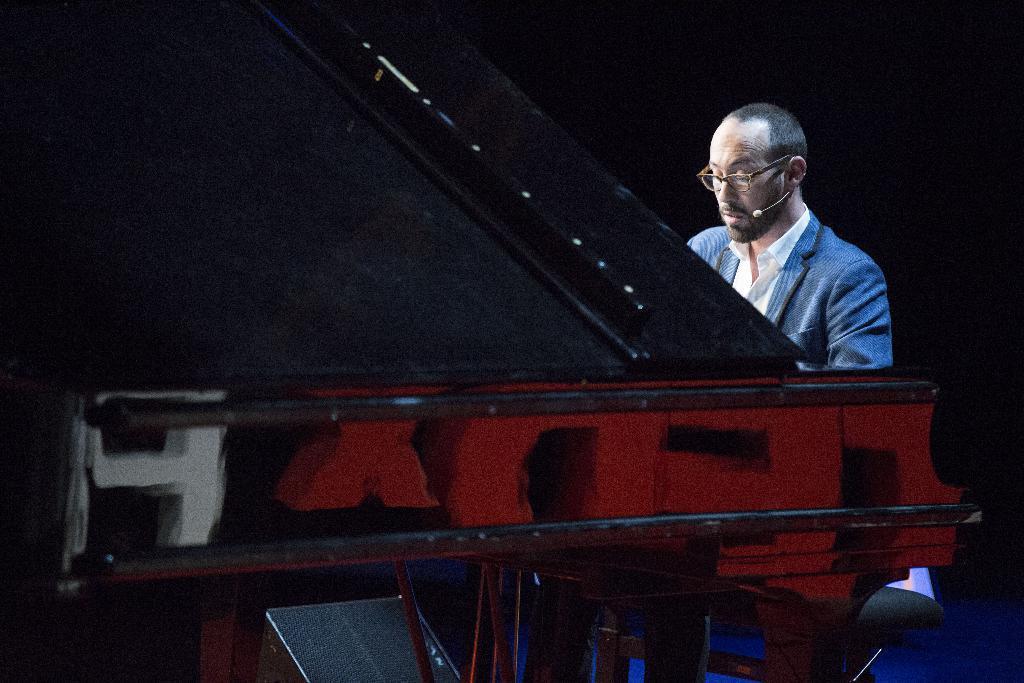Can you describe this image briefly? In this image there is a person wearing blue color suit playing a musical instrument. 